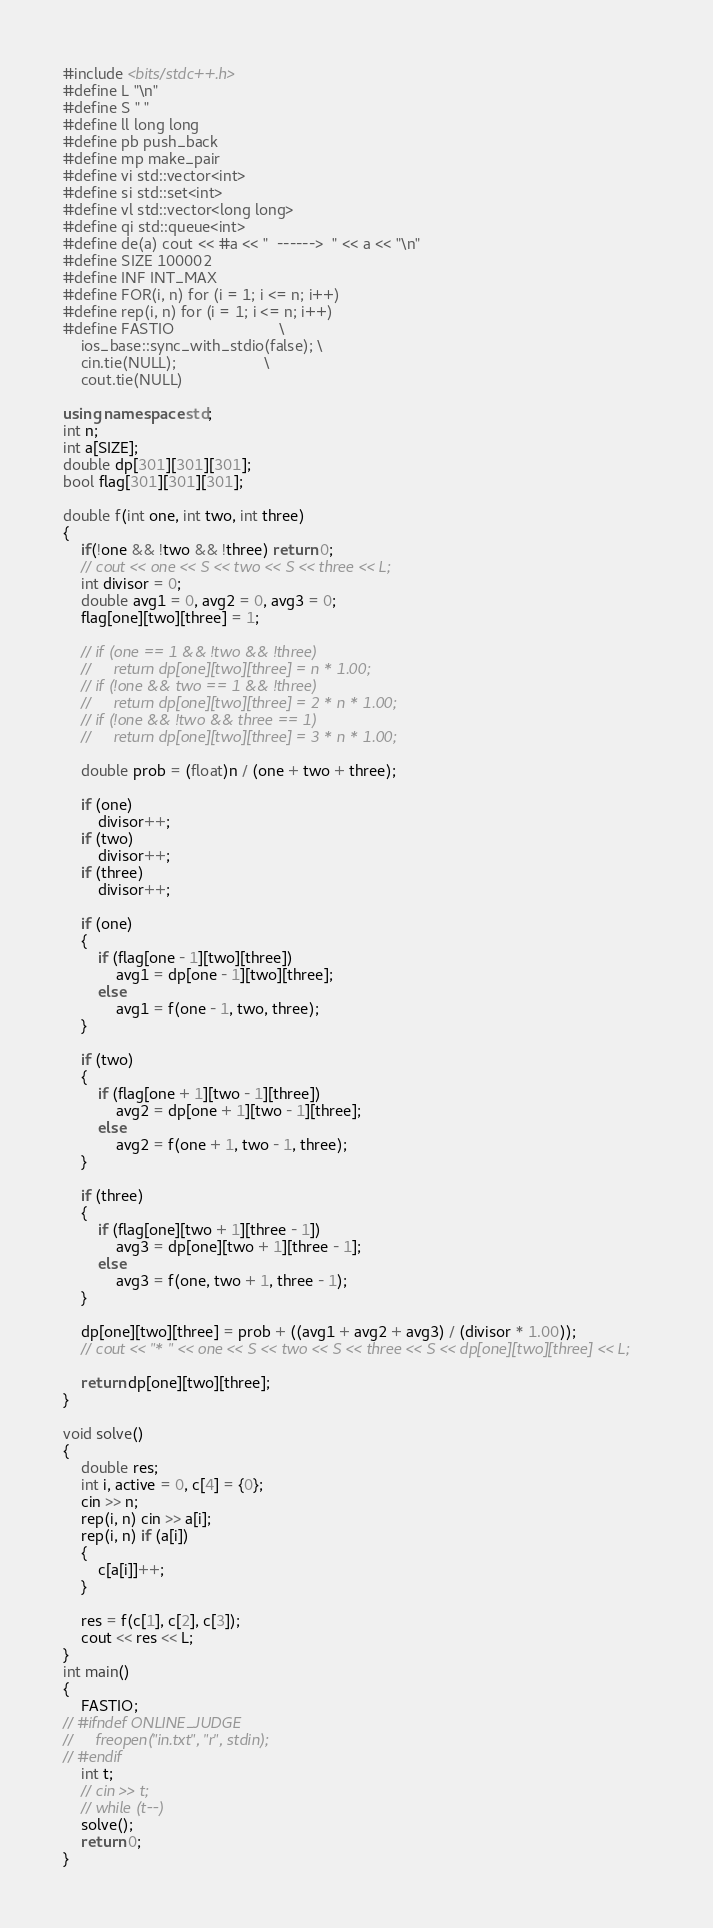<code> <loc_0><loc_0><loc_500><loc_500><_C++_>#include <bits/stdc++.h>
#define L "\n"
#define S " "
#define ll long long
#define pb push_back
#define mp make_pair
#define vi std::vector<int>
#define si std::set<int>
#define vl std::vector<long long>
#define qi std::queue<int>
#define de(a) cout << #a << "  ------>  " << a << "\n"
#define SIZE 100002
#define INF INT_MAX
#define FOR(i, n) for (i = 1; i <= n; i++)
#define rep(i, n) for (i = 1; i <= n; i++)
#define FASTIO                        \
    ios_base::sync_with_stdio(false); \
    cin.tie(NULL);                    \
    cout.tie(NULL)

using namespace std;
int n;
int a[SIZE];
double dp[301][301][301];
bool flag[301][301][301];

double f(int one, int two, int three)
{
    if(!one && !two && !three) return 0;
    // cout << one << S << two << S << three << L;
    int divisor = 0;
    double avg1 = 0, avg2 = 0, avg3 = 0;
    flag[one][two][three] = 1;

    // if (one == 1 && !two && !three)
    //     return dp[one][two][three] = n * 1.00;
    // if (!one && two == 1 && !three)
    //     return dp[one][two][three] = 2 * n * 1.00;
    // if (!one && !two && three == 1)
    //     return dp[one][two][three] = 3 * n * 1.00;

    double prob = (float)n / (one + two + three);

    if (one)
        divisor++;
    if (two)
        divisor++;
    if (three)
        divisor++;

    if (one)
    {
        if (flag[one - 1][two][three])
            avg1 = dp[one - 1][two][three];
        else
            avg1 = f(one - 1, two, three);
    }

    if (two)
    {
        if (flag[one + 1][two - 1][three])
            avg2 = dp[one + 1][two - 1][three];
        else
            avg2 = f(one + 1, two - 1, three);
    }

    if (three)
    {
        if (flag[one][two + 1][three - 1])
            avg3 = dp[one][two + 1][three - 1];
        else
            avg3 = f(one, two + 1, three - 1);
    }

    dp[one][two][three] = prob + ((avg1 + avg2 + avg3) / (divisor * 1.00));
    // cout << "* " << one << S << two << S << three << S << dp[one][two][three] << L;

    return dp[one][two][three];
}

void solve()
{
    double res;
    int i, active = 0, c[4] = {0};
    cin >> n;
    rep(i, n) cin >> a[i];
    rep(i, n) if (a[i])
    {
        c[a[i]]++;
    }

    res = f(c[1], c[2], c[3]);
    cout << res << L;
}
int main()
{
    FASTIO;
// #ifndef ONLINE_JUDGE
//     freopen("in.txt", "r", stdin);
// #endif
    int t;
    // cin >> t;
    // while (t--)
    solve();
    return 0;
}</code> 